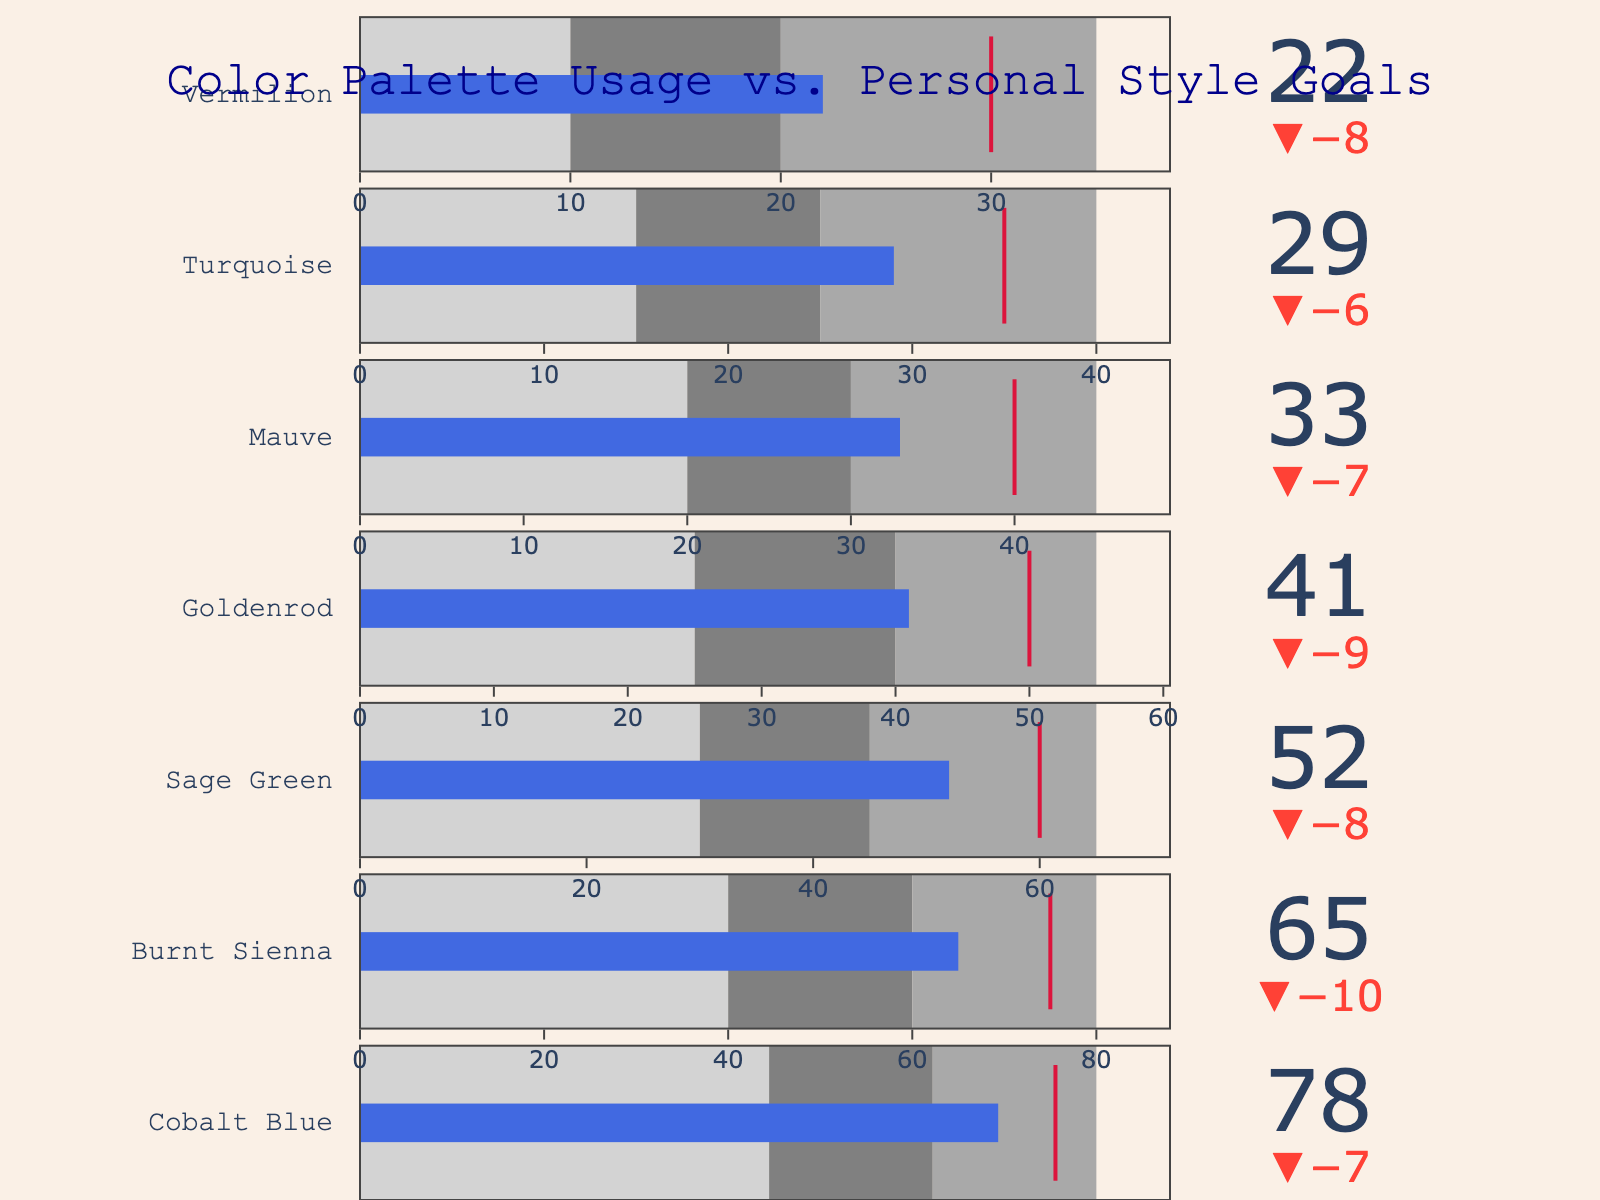What's the title of the figure? The title is displayed at the top of the figure. It reads "Color Palette Usage vs. Personal Style Goals".
Answer: Color Palette Usage vs. Personal Style Goals How many colors are analyzed in the figure? By counting the number of individual data entries with separate titles displayed as bullet charts, we see there are seven colors analyzed.
Answer: Seven Which color has the highest actual usage frequency? Review the bullet charts and compare the 'Actual' values of each color. The color with the highest actual usage frequency is Cobalt Blue, with a value of 78.
Answer: Cobalt Blue What is the target usage frequency for Vermilion? Find the Vermilion bullet chart and locate its target usage frequency; it is marked by a threshold line. The target usage frequency for Vermilion is 30.
Answer: 30 How much does the actual frequency of Goldenrod fall short of its target? Subtract the actual frequency (41) from the target frequency (50) for Goldenrod. The difference is the shortfall.
Answer: 9 Which color shows the smallest difference between actual and target usage frequencies? Calculate the difference between the actual and target values for each color and identify the smallest value. Mauve has the smallest difference of 7 (40 - 33).
Answer: Mauve Are there any colors for which the actual usage exceeds the target? Check each bullet chart to see if the actual value surpasses the target value. For none of the colors does the actual usage exceed the target.
Answer: No What is the range of values that is considered the best for Cobalt Blue? The 'Range3' for Cobalt Blue is highlighted, which marks the upper bound of the best range. For Cobalt Blue, the range is 70 to 90.
Answer: 70 to 90 Which color has the largest range for the best usage? Compare the 'Range3' values of all colors. Cobalt Blue has the largest best range, which is from 70 to 90, giving a span of 20 units.
Answer: Cobalt Blue What is the total sum of the target frequencies for all colors analyzed? Summing the target values for all colors: 85 (Cobalt Blue) + 75 (Burnt Sienna) + 60 (Sage Green) + 50 (Goldenrod) + 40 (Mauve) + 35 (Turquoise) + 30 (Vermilion) = 375.
Answer: 375 